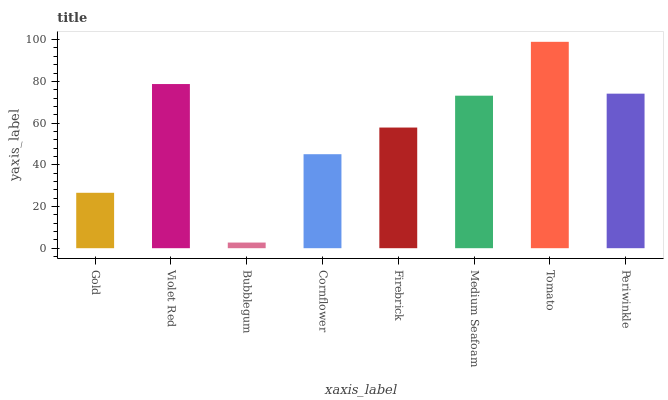Is Bubblegum the minimum?
Answer yes or no. Yes. Is Tomato the maximum?
Answer yes or no. Yes. Is Violet Red the minimum?
Answer yes or no. No. Is Violet Red the maximum?
Answer yes or no. No. Is Violet Red greater than Gold?
Answer yes or no. Yes. Is Gold less than Violet Red?
Answer yes or no. Yes. Is Gold greater than Violet Red?
Answer yes or no. No. Is Violet Red less than Gold?
Answer yes or no. No. Is Medium Seafoam the high median?
Answer yes or no. Yes. Is Firebrick the low median?
Answer yes or no. Yes. Is Violet Red the high median?
Answer yes or no. No. Is Tomato the low median?
Answer yes or no. No. 